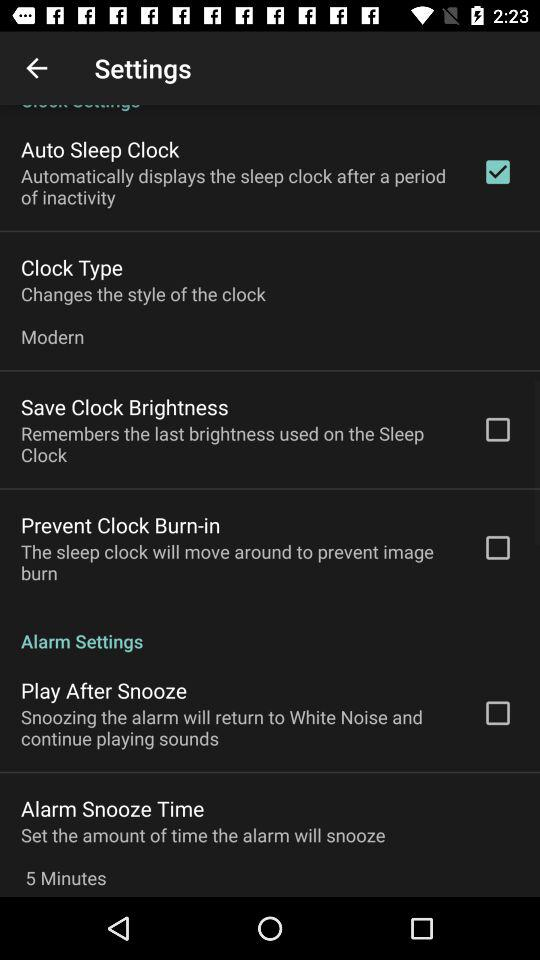What is the alarm snooze time? The alarm snooze time is 5 minutes. 